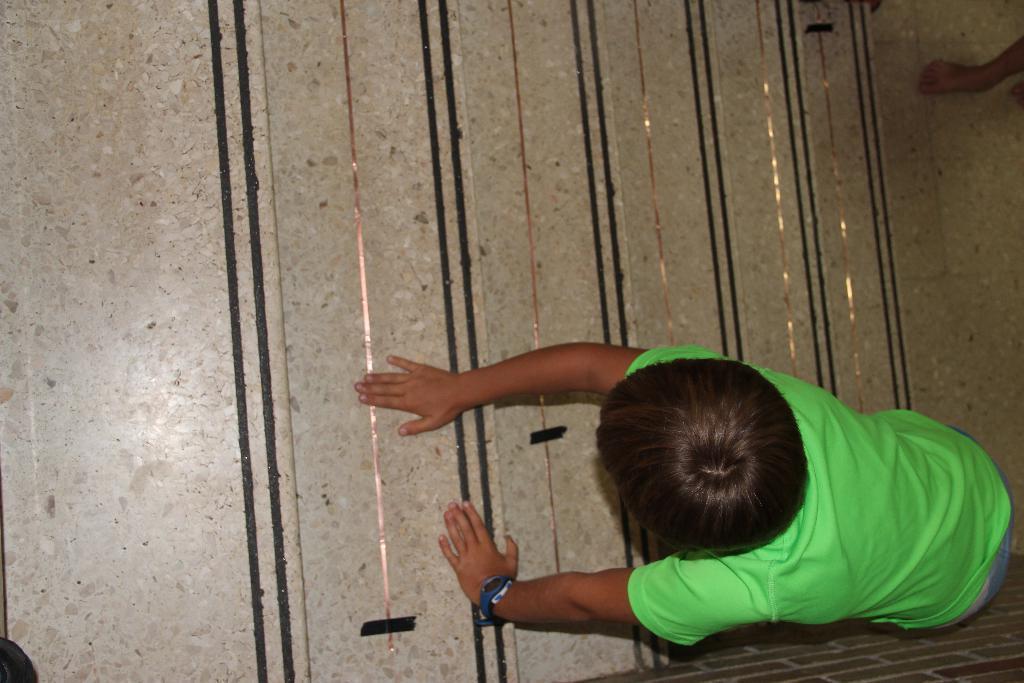Can you describe this image briefly? In this picture there is a kid placed one of his hand on the ground and the another hand on an object and there is a leg of a person in the right top corner. 